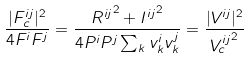Convert formula to latex. <formula><loc_0><loc_0><loc_500><loc_500>\frac { | F _ { c } ^ { i j } | ^ { 2 } } { 4 F ^ { i } F ^ { j } } = \frac { { R ^ { i j } } ^ { 2 } + { I ^ { i j } } ^ { 2 } } { 4 P ^ { i } P ^ { j } \sum _ { k } v _ { k } ^ { i } v _ { k } ^ { j } } = \frac { | V ^ { i j } | ^ { 2 } } { { V _ { c } ^ { i j } } ^ { 2 } }</formula> 